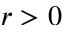<formula> <loc_0><loc_0><loc_500><loc_500>r > 0</formula> 